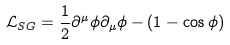<formula> <loc_0><loc_0><loc_500><loc_500>{ \mathcal { L } } _ { S G } = \frac { 1 } { 2 } \partial ^ { \mu } \phi \partial _ { \mu } \phi - ( 1 - \cos \phi )</formula> 